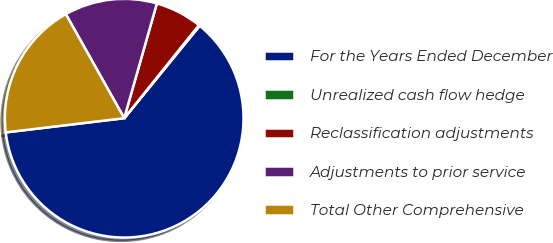<chart> <loc_0><loc_0><loc_500><loc_500><pie_chart><fcel>For the Years Ended December<fcel>Unrealized cash flow hedge<fcel>Reclassification adjustments<fcel>Adjustments to prior service<fcel>Total Other Comprehensive<nl><fcel>62.2%<fcel>0.14%<fcel>6.35%<fcel>12.55%<fcel>18.76%<nl></chart> 